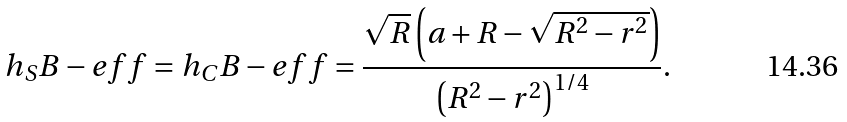Convert formula to latex. <formula><loc_0><loc_0><loc_500><loc_500>h _ { S } B - e f f = h _ { C } B - e f f & = \frac { \sqrt { R } \left ( a + R - \sqrt { R ^ { 2 } - r ^ { 2 } } \right ) } { \left ( R ^ { 2 } - r ^ { 2 } \right ) ^ { 1 / 4 } } .</formula> 